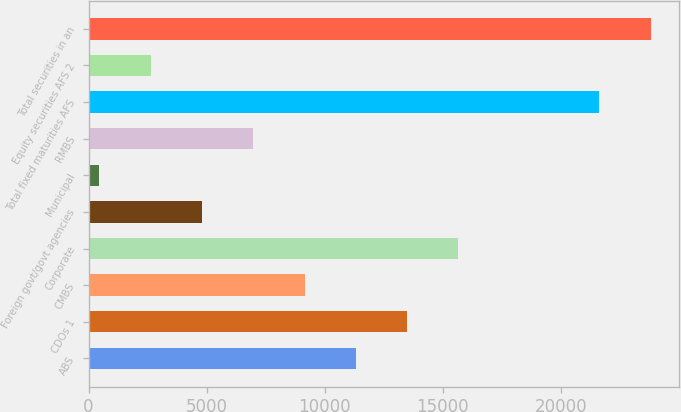Convert chart to OTSL. <chart><loc_0><loc_0><loc_500><loc_500><bar_chart><fcel>ABS<fcel>CDOs 1<fcel>CMBS<fcel>Corporate<fcel>Foreign govt/govt agencies<fcel>Municipal<fcel>RMBS<fcel>Total fixed maturities AFS<fcel>Equity securities AFS 2<fcel>Total securities in an<nl><fcel>11312.5<fcel>13483.4<fcel>9141.6<fcel>15654.3<fcel>4799.8<fcel>458<fcel>6970.7<fcel>21625<fcel>2628.9<fcel>23795.9<nl></chart> 